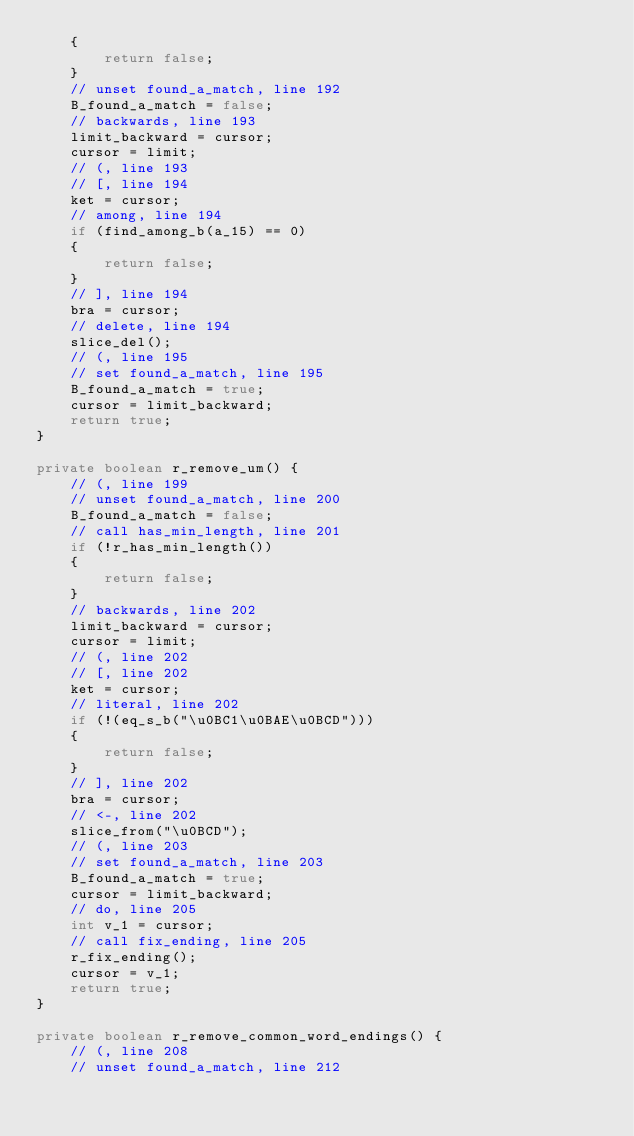Convert code to text. <code><loc_0><loc_0><loc_500><loc_500><_Java_>    {
        return false;
    }
    // unset found_a_match, line 192
    B_found_a_match = false;
    // backwards, line 193
    limit_backward = cursor;
    cursor = limit;
    // (, line 193
    // [, line 194
    ket = cursor;
    // among, line 194
    if (find_among_b(a_15) == 0)
    {
        return false;
    }
    // ], line 194
    bra = cursor;
    // delete, line 194
    slice_del();
    // (, line 195
    // set found_a_match, line 195
    B_found_a_match = true;
    cursor = limit_backward;
    return true;
}

private boolean r_remove_um() {
    // (, line 199
    // unset found_a_match, line 200
    B_found_a_match = false;
    // call has_min_length, line 201
    if (!r_has_min_length())
    {
        return false;
    }
    // backwards, line 202
    limit_backward = cursor;
    cursor = limit;
    // (, line 202
    // [, line 202
    ket = cursor;
    // literal, line 202
    if (!(eq_s_b("\u0BC1\u0BAE\u0BCD")))
    {
        return false;
    }
    // ], line 202
    bra = cursor;
    // <-, line 202
    slice_from("\u0BCD");
    // (, line 203
    // set found_a_match, line 203
    B_found_a_match = true;
    cursor = limit_backward;
    // do, line 205
    int v_1 = cursor;
    // call fix_ending, line 205
    r_fix_ending();
    cursor = v_1;
    return true;
}

private boolean r_remove_common_word_endings() {
    // (, line 208
    // unset found_a_match, line 212</code> 